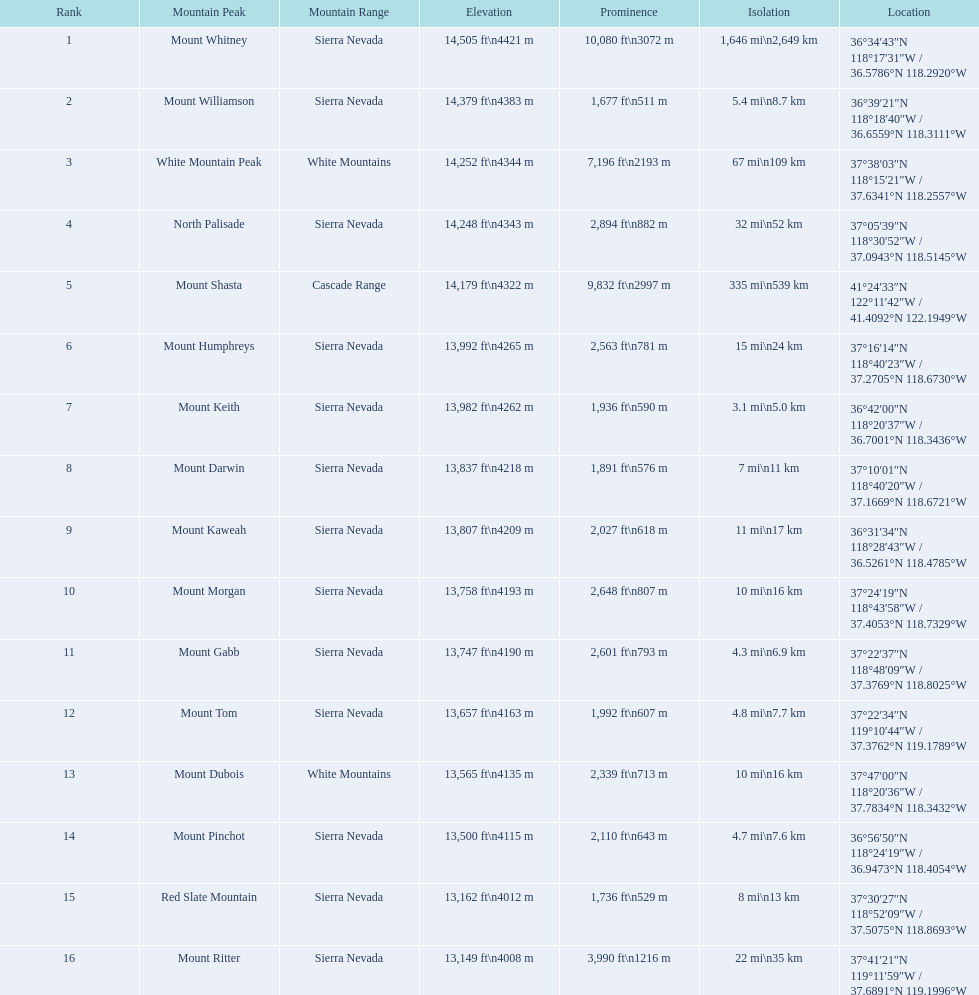Which mountain top is associated with the sierra nevada mountain range? Mount Whitney. What peak has an altitude of 14,379 feet? Mount Williamson. What mountain belongs to the cascade range? Mount Shasta. 